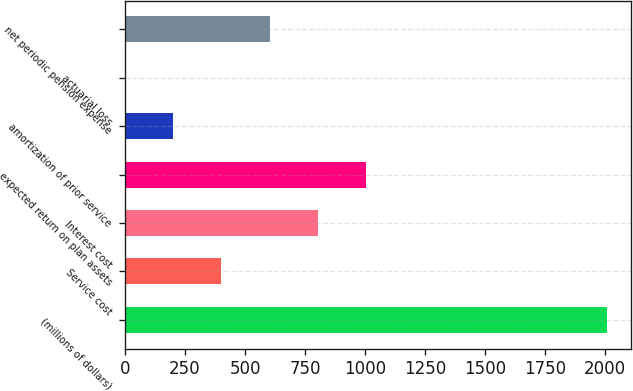Convert chart to OTSL. <chart><loc_0><loc_0><loc_500><loc_500><bar_chart><fcel>(millions of dollars)<fcel>Service cost<fcel>Interest cost<fcel>expected return on plan assets<fcel>amortization of prior service<fcel>actuarial loss<fcel>net periodic pension expense<nl><fcel>2007<fcel>401.88<fcel>803.16<fcel>1003.8<fcel>201.24<fcel>0.6<fcel>602.52<nl></chart> 